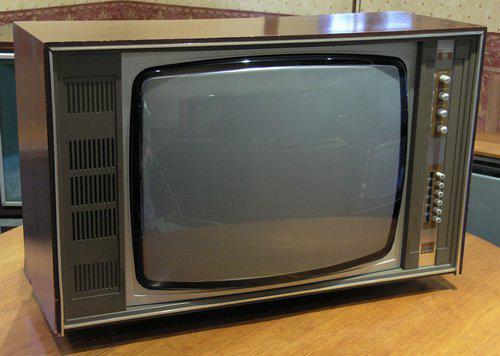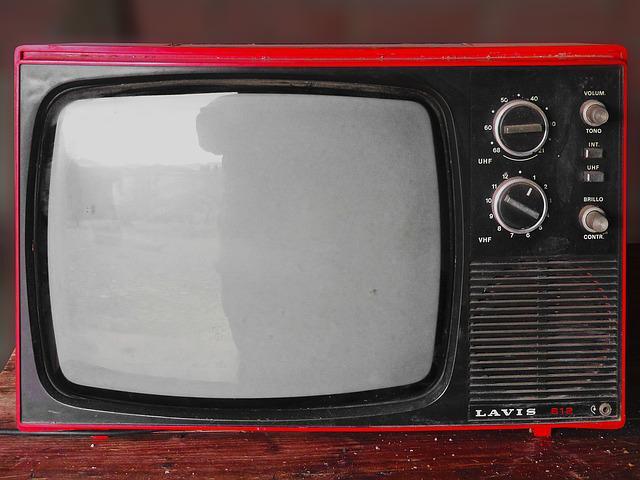The first image is the image on the left, the second image is the image on the right. For the images shown, is this caption "The right image contains a TV with a reddish-orange case and two large dials to the right of its screen." true? Answer yes or no. Yes. The first image is the image on the left, the second image is the image on the right. Considering the images on both sides, is "In one of the images there is a red television with rotary knobs." valid? Answer yes or no. Yes. 